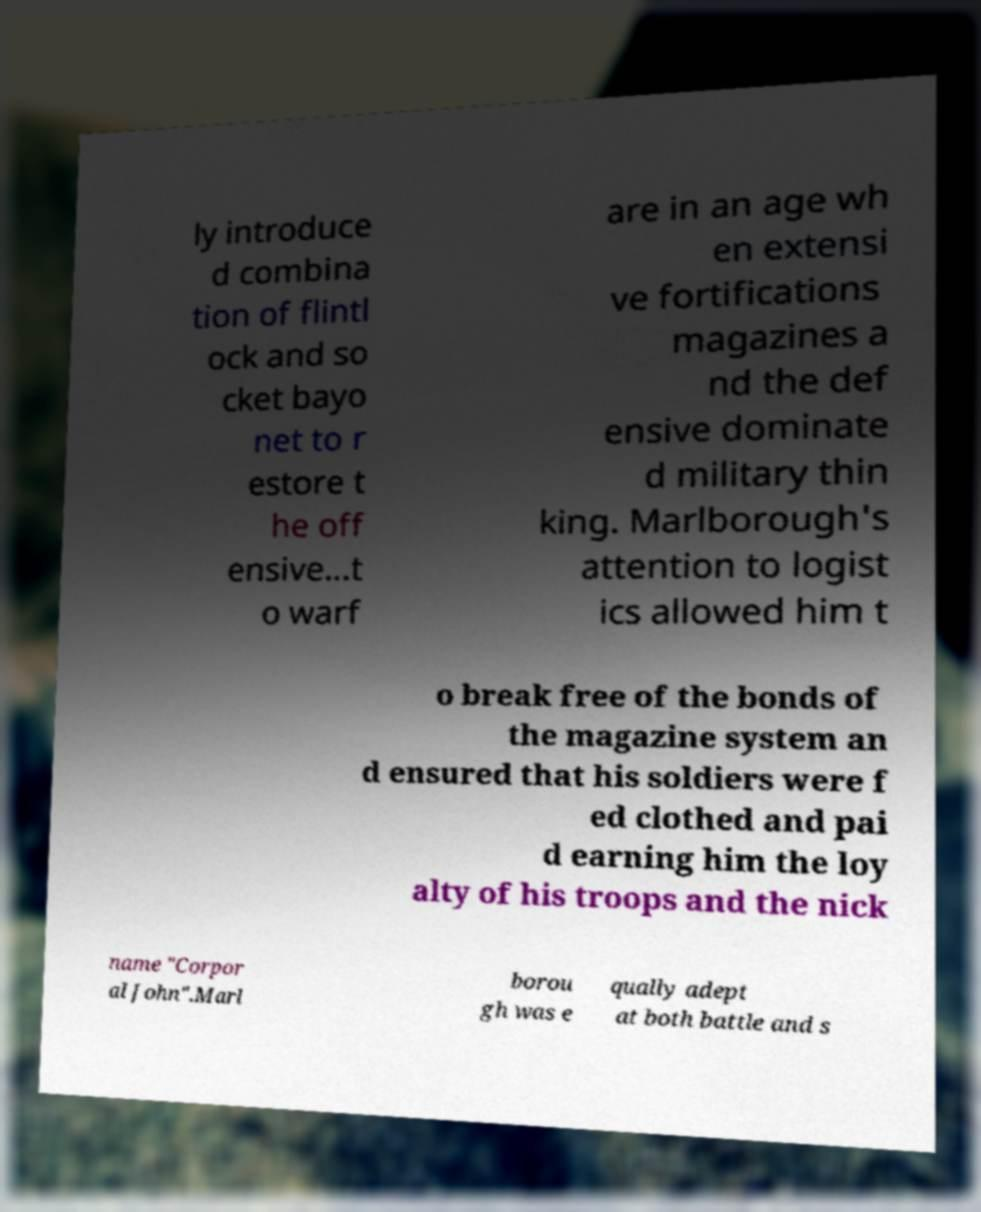Please read and relay the text visible in this image. What does it say? ly introduce d combina tion of flintl ock and so cket bayo net to r estore t he off ensive...t o warf are in an age wh en extensi ve fortifications magazines a nd the def ensive dominate d military thin king. Marlborough's attention to logist ics allowed him t o break free of the bonds of the magazine system an d ensured that his soldiers were f ed clothed and pai d earning him the loy alty of his troops and the nick name "Corpor al John".Marl borou gh was e qually adept at both battle and s 